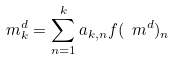Convert formula to latex. <formula><loc_0><loc_0><loc_500><loc_500>m _ { k } ^ { d } = \sum _ { n = 1 } ^ { k } a _ { k , n } f ( \ m ^ { d } ) _ { n }</formula> 